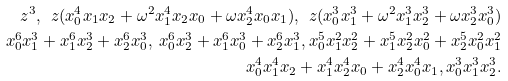Convert formula to latex. <formula><loc_0><loc_0><loc_500><loc_500>z ^ { 3 } , \ z ( x _ { 0 } ^ { 4 } x _ { 1 } x _ { 2 } + \omega ^ { 2 } x _ { 1 } ^ { 4 } x _ { 2 } x _ { 0 } + \omega x _ { 2 } ^ { 4 } x _ { 0 } x _ { 1 } ) , \ z ( x _ { 0 } ^ { 3 } x _ { 1 } ^ { 3 } + \omega ^ { 2 } x _ { 1 } ^ { 3 } x _ { 2 } ^ { 3 } + \omega x _ { 2 } ^ { 3 } x _ { 0 } ^ { 3 } ) \\ x _ { 0 } ^ { 6 } x _ { 1 } ^ { 3 } + x _ { 1 } ^ { 6 } x _ { 2 } ^ { 3 } + x _ { 2 } ^ { 6 } x _ { 0 } ^ { 3 } , \ x _ { 0 } ^ { 6 } x _ { 2 } ^ { 3 } + x _ { 1 } ^ { 6 } x _ { 0 } ^ { 3 } + x _ { 2 } ^ { 6 } x _ { 1 } ^ { 3 } , x _ { 0 } ^ { 5 } x _ { 1 } ^ { 2 } x _ { 2 } ^ { 2 } + x _ { 1 } ^ { 5 } x _ { 2 } ^ { 2 } x _ { 0 } ^ { 2 } + x _ { 2 } ^ { 5 } x _ { 0 } ^ { 2 } x _ { 1 } ^ { 2 } \\ x _ { 0 } ^ { 4 } x _ { 1 } ^ { 4 } x _ { 2 } + x _ { 1 } ^ { 4 } x _ { 2 } ^ { 4 } x _ { 0 } + x _ { 2 } ^ { 4 } x _ { 0 } ^ { 4 } x _ { 1 } , x _ { 0 } ^ { 3 } x _ { 1 } ^ { 3 } x _ { 2 } ^ { 3 } .</formula> 